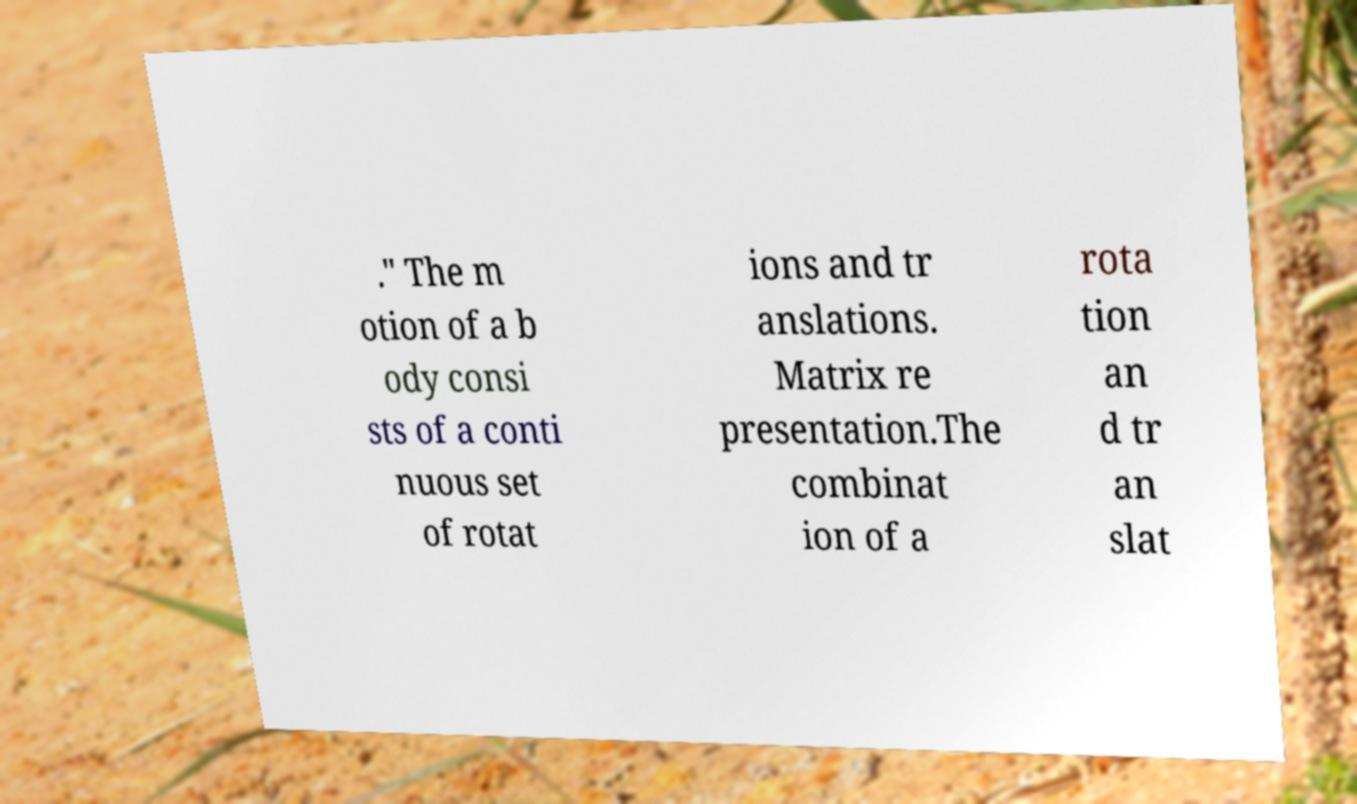For documentation purposes, I need the text within this image transcribed. Could you provide that? ." The m otion of a b ody consi sts of a conti nuous set of rotat ions and tr anslations. Matrix re presentation.The combinat ion of a rota tion an d tr an slat 